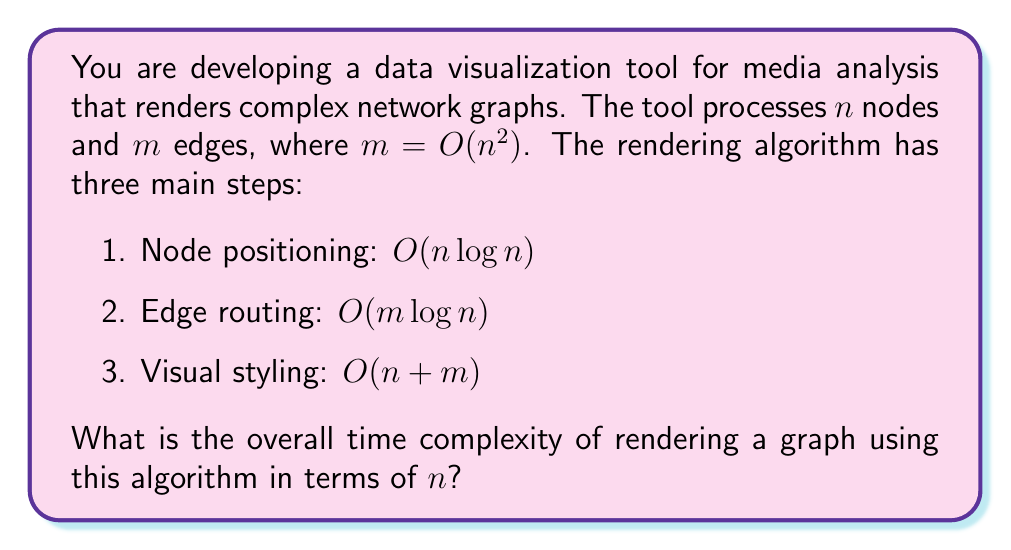Give your solution to this math problem. To determine the overall time complexity, we need to analyze each step and combine them:

1. Node positioning: $O(n \log n)$
   This step remains as is.

2. Edge routing: $O(m \log n)$
   We know that $m = O(n^2)$, so we can substitute:
   $O(m \log n) = O(n^2 \log n)$

3. Visual styling: $O(n + m)$
   Again, substituting $m = O(n^2)$:
   $O(n + m) = O(n + n^2) = O(n^2)$

Now, we have three terms:
- $O(n \log n)$
- $O(n^2 \log n)$
- $O(n^2)$

To find the overall time complexity, we need to consider the dominant term. We can see that:

$O(n \log n) < O(n^2) < O(n^2 \log n)$

Therefore, the dominant term is $O(n^2 \log n)$, which represents the overall time complexity of the algorithm.
Answer: The overall time complexity is $O(n^2 \log n)$. 